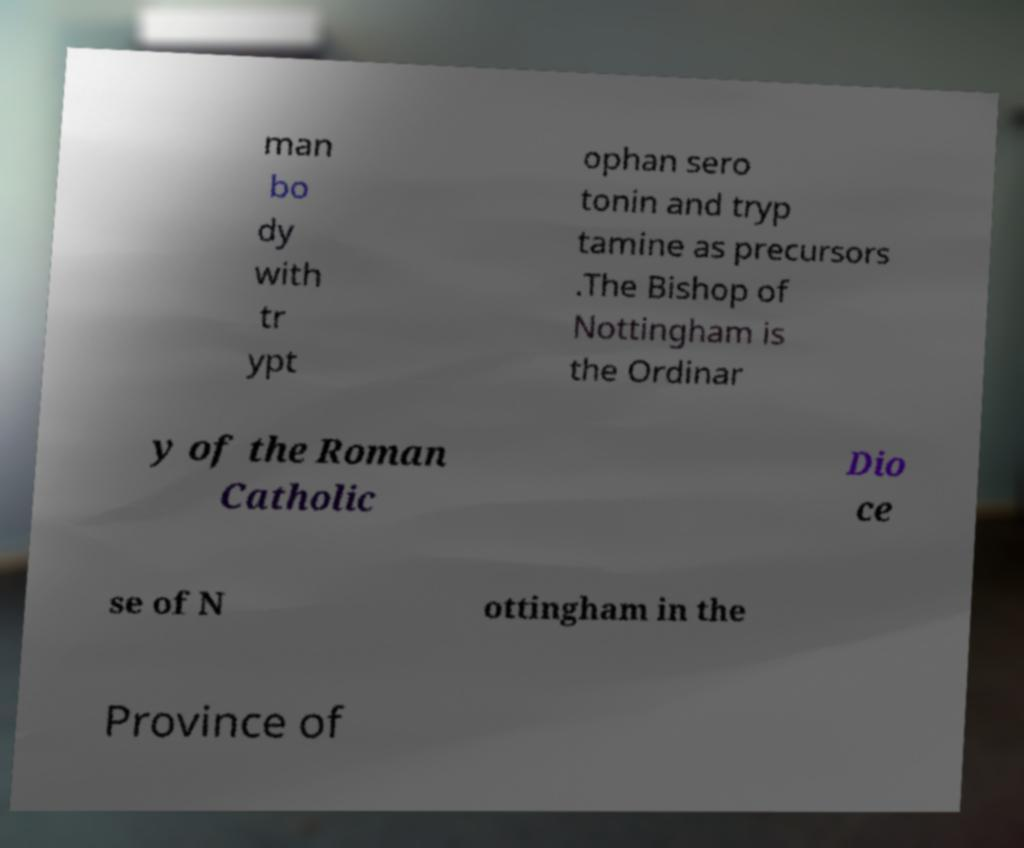Can you accurately transcribe the text from the provided image for me? man bo dy with tr ypt ophan sero tonin and tryp tamine as precursors .The Bishop of Nottingham is the Ordinar y of the Roman Catholic Dio ce se of N ottingham in the Province of 